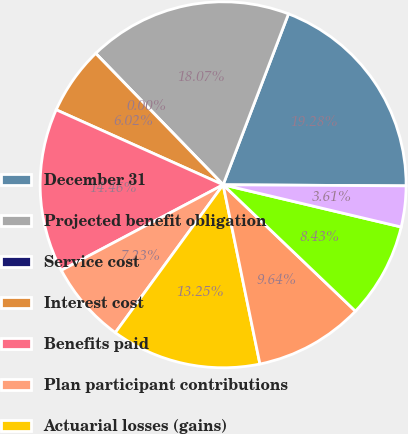<chart> <loc_0><loc_0><loc_500><loc_500><pie_chart><fcel>December 31<fcel>Projected benefit obligation<fcel>Service cost<fcel>Interest cost<fcel>Benefits paid<fcel>Plan participant contributions<fcel>Actuarial losses (gains)<fcel>Settlements and curtailments<fcel>Foreign currency effect<fcel>Other<nl><fcel>19.28%<fcel>18.07%<fcel>0.0%<fcel>6.02%<fcel>14.46%<fcel>7.23%<fcel>13.25%<fcel>9.64%<fcel>8.43%<fcel>3.61%<nl></chart> 